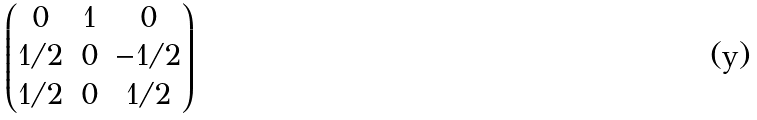Convert formula to latex. <formula><loc_0><loc_0><loc_500><loc_500>\begin{pmatrix} 0 & 1 & 0 \\ 1 \slash 2 & 0 & - 1 \slash 2 \\ 1 \slash 2 & 0 & 1 \slash 2 \\ \end{pmatrix}</formula> 